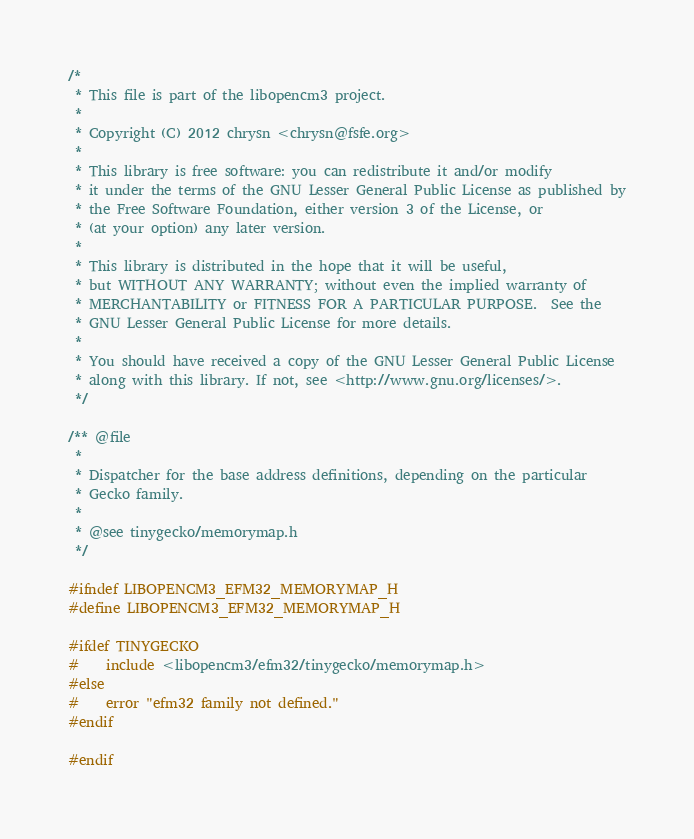<code> <loc_0><loc_0><loc_500><loc_500><_C_>/*
 * This file is part of the libopencm3 project.
 *
 * Copyright (C) 2012 chrysn <chrysn@fsfe.org>
 *
 * This library is free software: you can redistribute it and/or modify
 * it under the terms of the GNU Lesser General Public License as published by
 * the Free Software Foundation, either version 3 of the License, or
 * (at your option) any later version.
 *
 * This library is distributed in the hope that it will be useful,
 * but WITHOUT ANY WARRANTY; without even the implied warranty of
 * MERCHANTABILITY or FITNESS FOR A PARTICULAR PURPOSE.  See the
 * GNU Lesser General Public License for more details.
 *
 * You should have received a copy of the GNU Lesser General Public License
 * along with this library. If not, see <http://www.gnu.org/licenses/>.
 */

/** @file
 *
 * Dispatcher for the base address definitions, depending on the particular
 * Gecko family.
 *
 * @see tinygecko/memorymap.h
 */

#ifndef LIBOPENCM3_EFM32_MEMORYMAP_H
#define LIBOPENCM3_EFM32_MEMORYMAP_H

#ifdef TINYGECKO
#	include <libopencm3/efm32/tinygecko/memorymap.h>
#else
#	error "efm32 family not defined."
#endif

#endif
</code> 